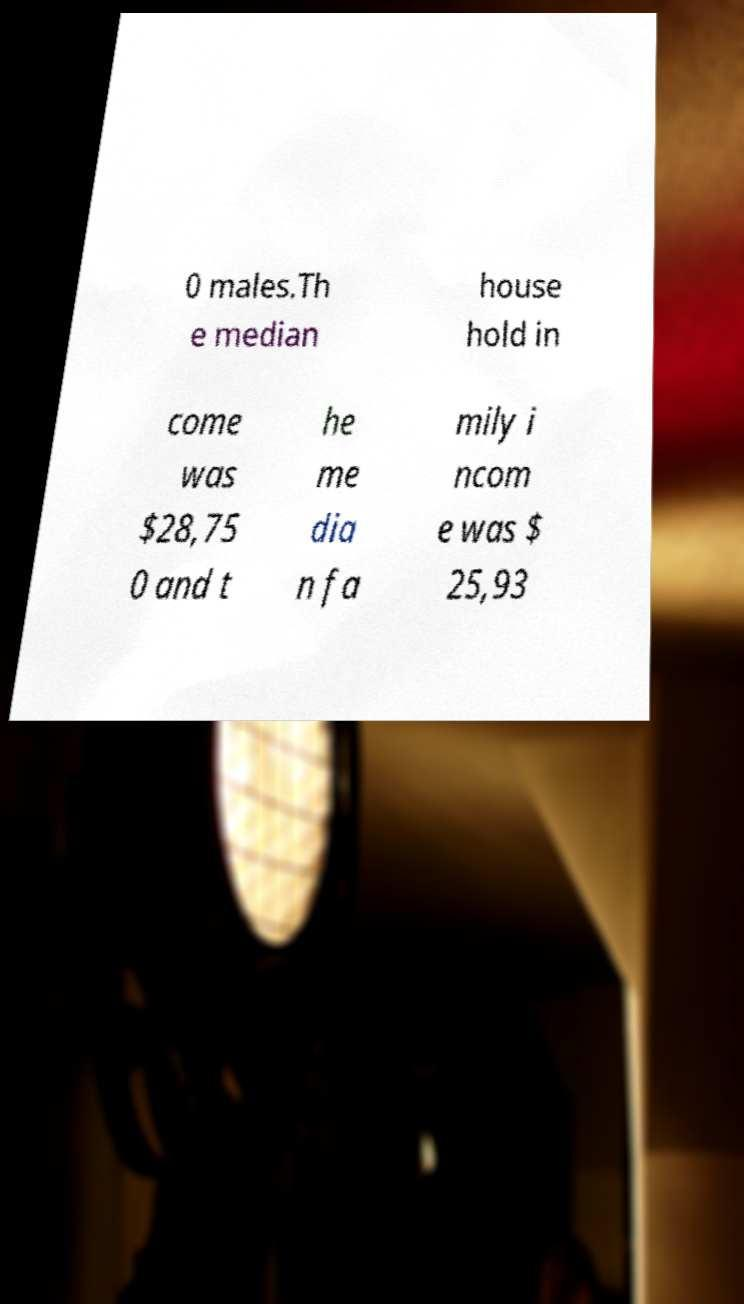Could you extract and type out the text from this image? 0 males.Th e median house hold in come was $28,75 0 and t he me dia n fa mily i ncom e was $ 25,93 